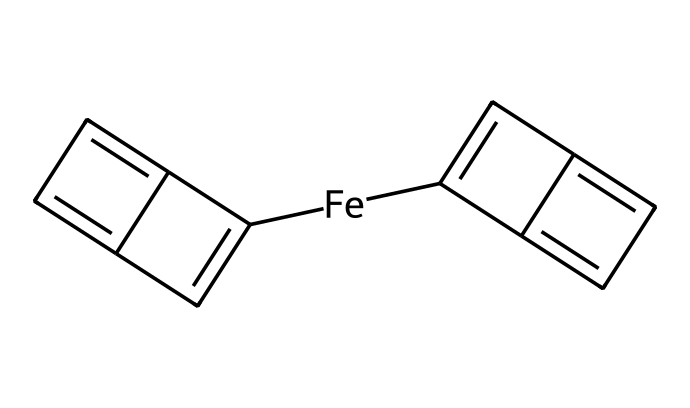What is the central metal atom in ferrocene? The SMILES representation indicates the presence of an iron atom represented by [Fe], which is recognized as the central metal atom in the structure of ferrocene.
Answer: iron How many cyclopentadienyl rings are present in ferrocene? Analyzing the chemical structure reveals two distinct components that resemble cyclopentadienyl structures (indicated by the C atoms arranged in a cyclical manner). This confirms that there are two cyclopentadienyl rings in ferrocene.
Answer: 2 What is the geometry of the central iron atom in ferrocene? In ferrocene, the iron atom interacts with two cyclopentadienyl anions positioned above and below it, creating a sandwich-like structure. This arrangement leads to a typical geometry of such organometallic compounds, which is often described as trigonal bipyramidal or distorted octahedral.
Answer: trigonal bipyramidal How many π electrons are in each cyclopentadienyl ring? Each cyclopentadienyl ring contains 5 carbon atoms, and it is a known fact that in aromatic systems each carbon contributes one π electron. Therefore, the total count of π electrons in one ring is 5.
Answer: 5 What type of bonding is primarily present in ferrocene? The bonding in ferrocene mainly comprises covalent bonding between the iron atom and the carbon atoms of the cyclopentadienyl rings, characterizing it as a metal–carbon bond typical in organometallic compounds.
Answer: covalent What is the overall charge of ferrocene? In the structural representation, ferrocene is composed of neutral iron and two neutral cyclopentadienyl rings, which leads to a net charge of zero for the entire compound.
Answer: 0 